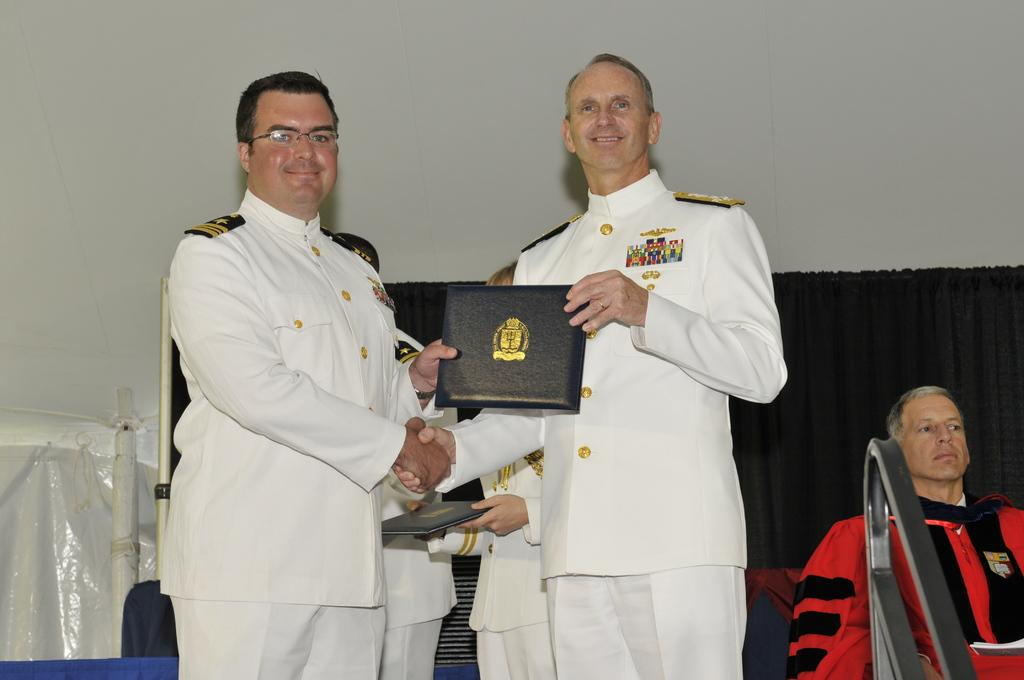How many people are present in the image? There are four people in the image. What are the people doing in the image? The people are standing in the image. What objects are the people holding? The people are holding books in the image. What can be seen in the background of the image? There is a wall and a curtain in the background of the image. How many balls can be seen rolling on the floor in the image? There are no balls visible in the image. Which person's leg is extended the furthest in the image? The image does not provide enough information to determine which person's leg is extended the furthest, as the people are standing and holding books. 